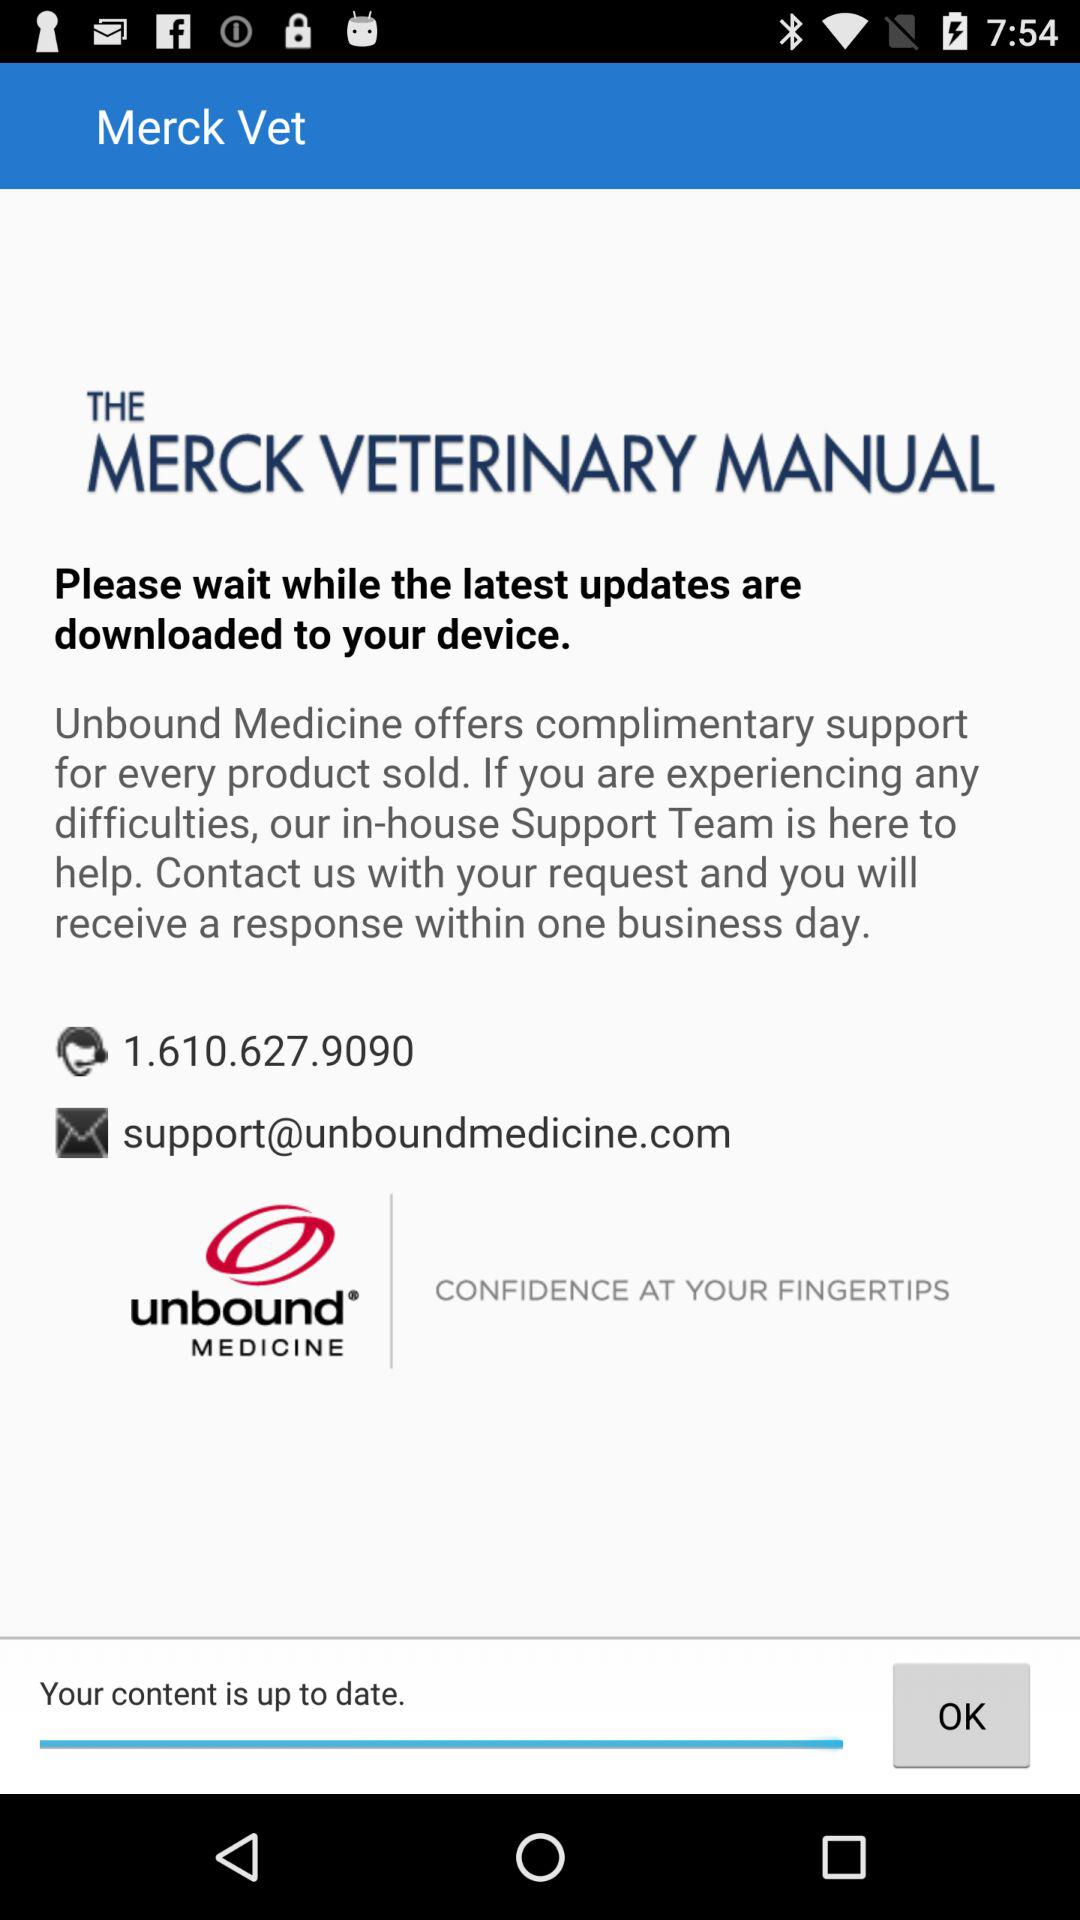What is the support email address? The support email address is support@unboundmedicine.com. 